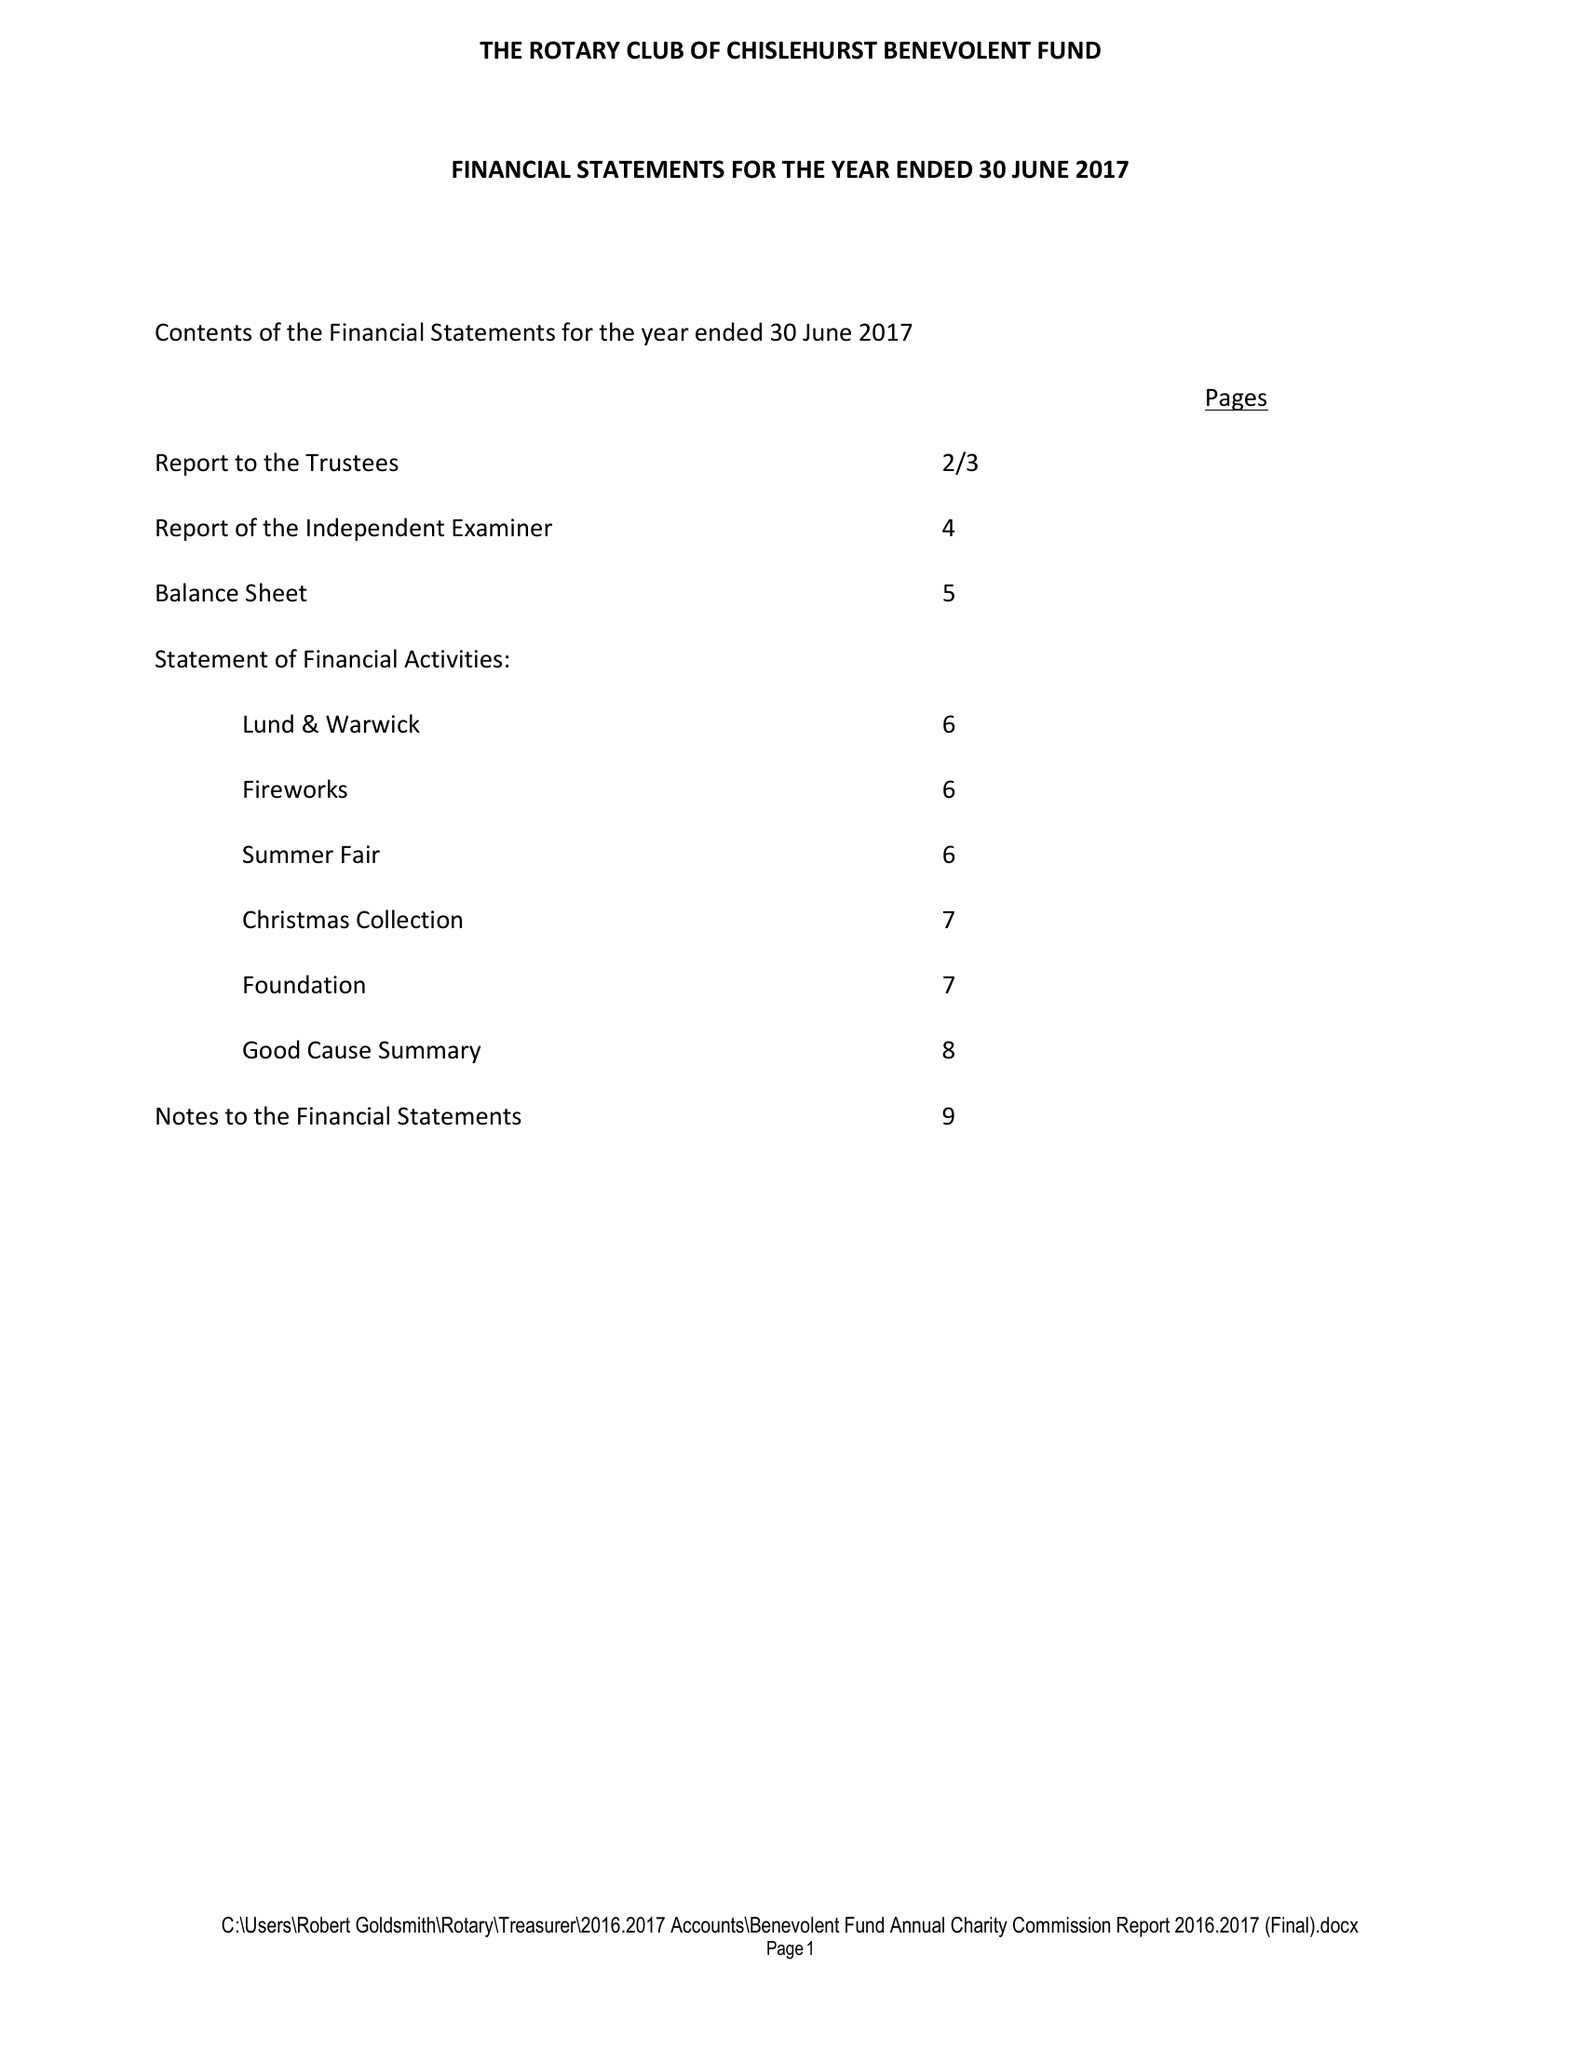What is the value for the address__street_line?
Answer the question using a single word or phrase. CHELSFIELD LANE 